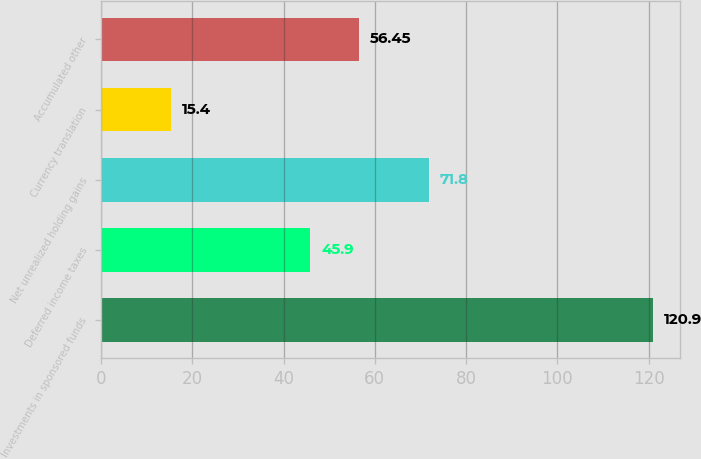<chart> <loc_0><loc_0><loc_500><loc_500><bar_chart><fcel>Investments in sponsored funds<fcel>Deferred income taxes<fcel>Net unrealized holding gains<fcel>Currency translation<fcel>Accumulated other<nl><fcel>120.9<fcel>45.9<fcel>71.8<fcel>15.4<fcel>56.45<nl></chart> 